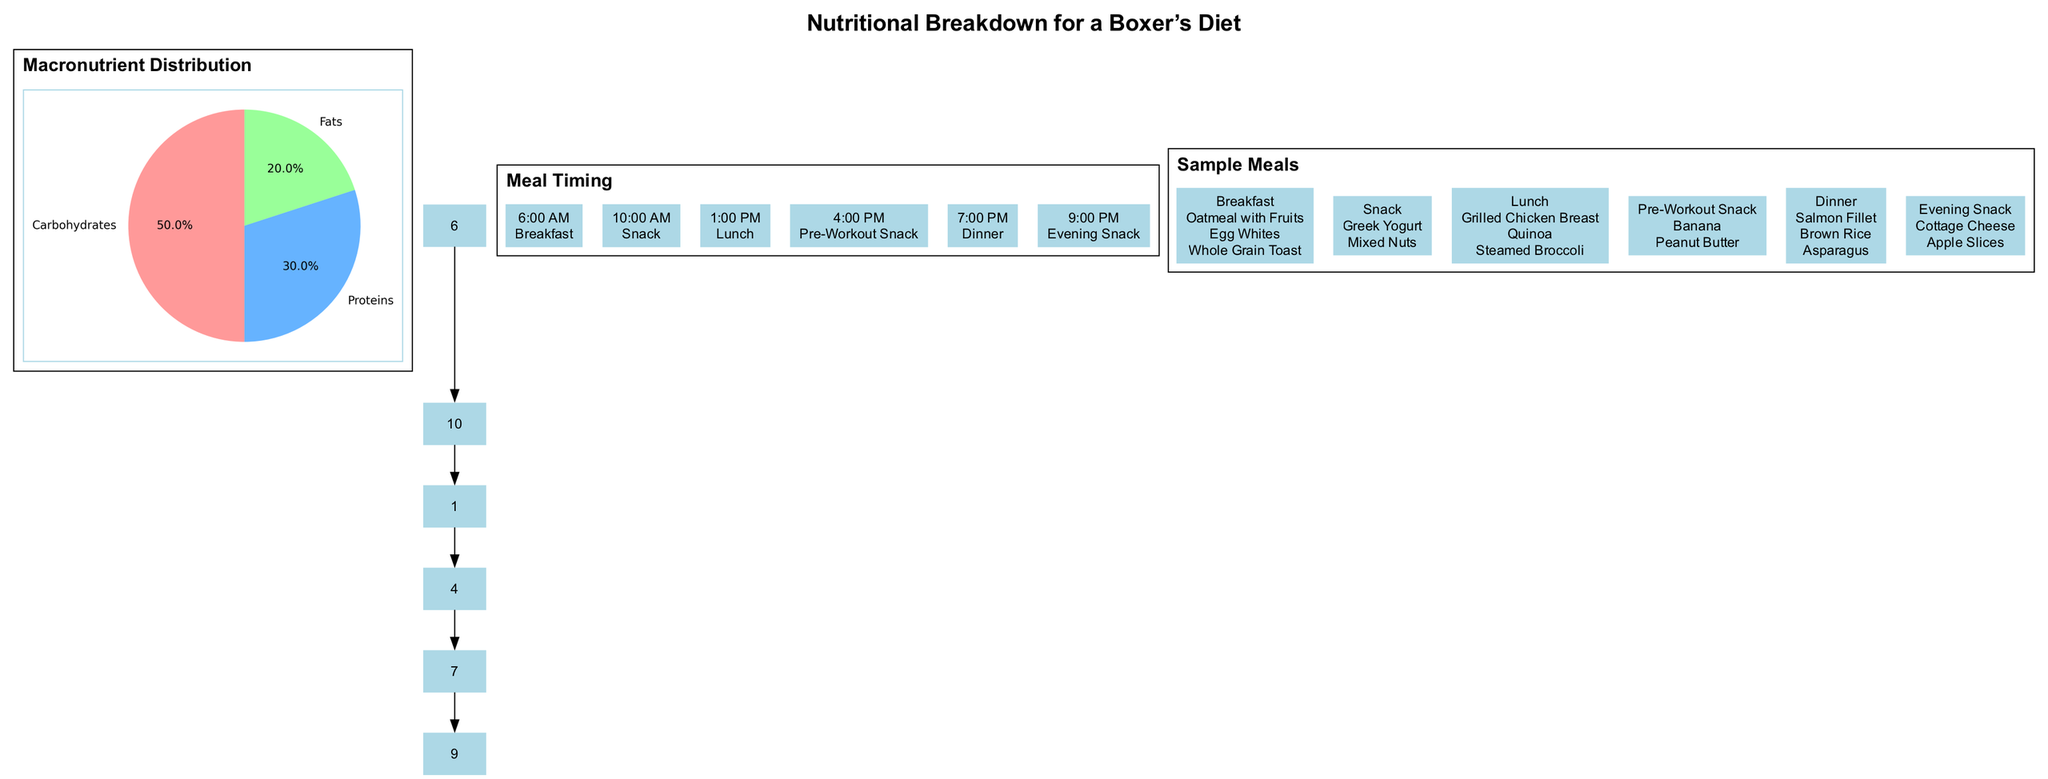What is the percentage of carbohydrates in the macronutrient distribution? The pie chart shows that carbohydrates constitute 50% of the total macronutrient distribution for the boxer's diet.
Answer: 50% How many meal times are listed in the diagram? There are six meal times listed in the meal timing section: Breakfast, Snack, Lunch, Pre-Workout Snack, Dinner, and Evening Snack.
Answer: 6 What is the main protein source in the sample lunch meal? The sample lunch meal lists Grilled Chicken Breast as the primary protein source, which is the first item listed under lunch.
Answer: Grilled Chicken Breast What time is designated for dinner? The dinner is scheduled for 7:00 PM, as indicated in the meal timing section.
Answer: 7:00 PM From the sample meals, what is included in the pre-workout snack? The pre-workout snack consists of a Banana and Peanut Butter, as shown in the sample meals section.
Answer: Banana, Peanut Butter Which macronutrient has the smallest percentage in the distribution? The pie chart illustrates that fats have the smallest percentage at 20%, which is less than carbohydrates and proteins.
Answer: Fats What is the total percentage of proteins and fats combined? Adding the percentages of proteins (30%) and fats (20%) gives a total of 50%. This is derived from the values in the macronutrient distribution.
Answer: 50% What meal comes right after breakfast according to meal timing? The meal that follows breakfast is the Snack, which is listed at 10:00 AM in the meal timing section.
Answer: Snack How many items are in the breakfast meal sample? The breakfast meal sample includes three items: Oatmeal with Fruits, Egg Whites, and Whole Grain Toast.
Answer: 3 